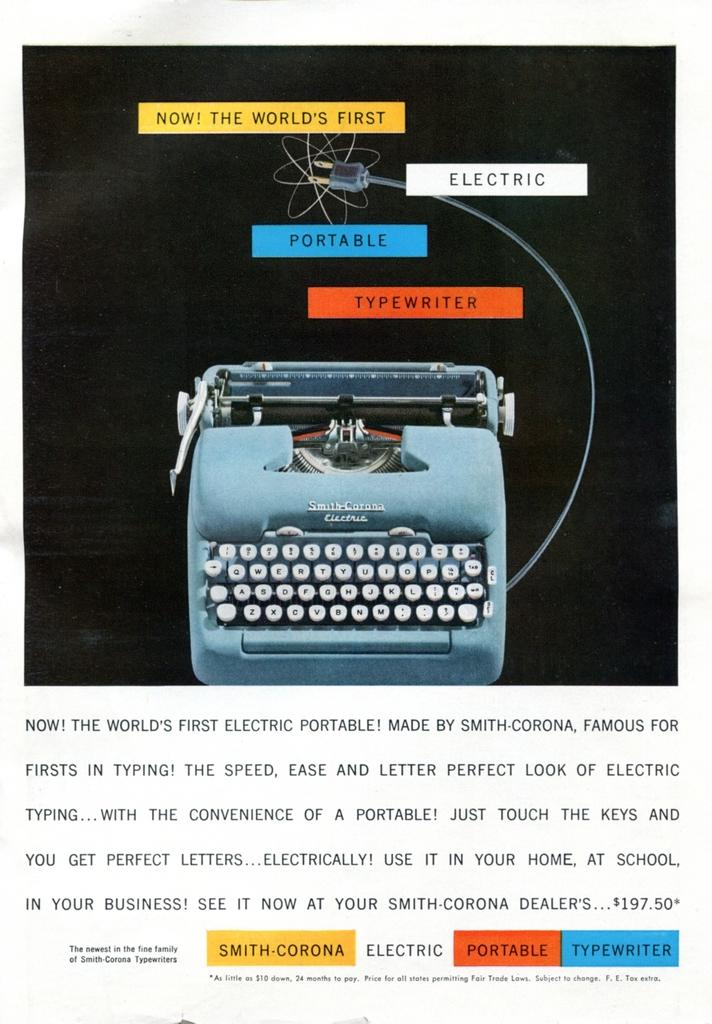<image>
Provide a brief description of the given image. A page for a typewriter yellow, red and blue highlited words like portable electric. 